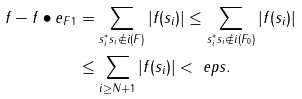<formula> <loc_0><loc_0><loc_500><loc_500>\| f - f \bullet e _ { F } \| _ { 1 } & = \sum _ { s _ { i } ^ { * } s _ { i } \notin i ( F ) } | f ( s _ { i } ) | \leq \sum _ { s _ { i } ^ { * } s _ { i } \notin i ( F _ { 0 } ) } | f ( s _ { i } ) | \\ & \leq \sum _ { i \geq N + 1 } | f ( s _ { i } ) | < \ e p s .</formula> 